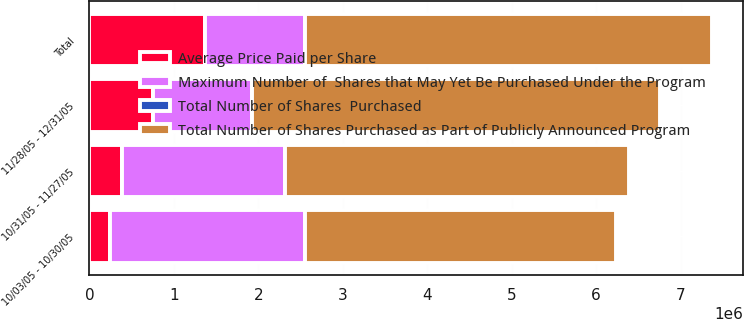Convert chart. <chart><loc_0><loc_0><loc_500><loc_500><stacked_bar_chart><ecel><fcel>10/03/05 - 10/30/05<fcel>10/31/05 - 11/27/05<fcel>11/28/05 - 12/31/05<fcel>Total<nl><fcel>Average Price Paid per Share<fcel>237500<fcel>382500<fcel>750500<fcel>1.3705e+06<nl><fcel>Total Number of Shares  Purchased<fcel>115.5<fcel>115.9<fcel>114.41<fcel>115.01<nl><fcel>Total Number of Shares Purchased as Part of Publicly Announced Program<fcel>3.6901e+06<fcel>4.0726e+06<fcel>4.8231e+06<fcel>4.8231e+06<nl><fcel>Maximum Number of  Shares that May Yet Be Purchased Under the Program<fcel>2.3099e+06<fcel>1.9274e+06<fcel>1.1769e+06<fcel>1.1769e+06<nl></chart> 